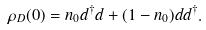Convert formula to latex. <formula><loc_0><loc_0><loc_500><loc_500>\rho _ { D } ( 0 ) = n _ { 0 } d ^ { \dagger } d + ( 1 - n _ { 0 } ) d d ^ { \dagger } .</formula> 